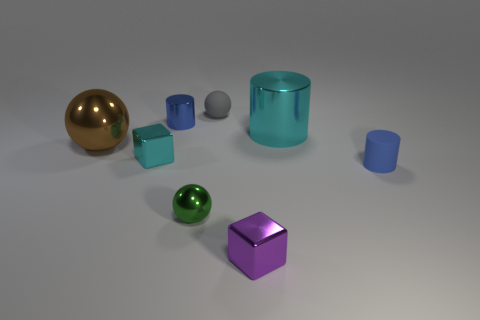There is another cylinder that is the same color as the small metallic cylinder; what is its material?
Offer a terse response. Rubber. Are there fewer small gray rubber things on the left side of the cyan cube than large brown shiny spheres behind the purple cube?
Provide a succinct answer. Yes. Do the tiny cylinder that is behind the small cyan metallic block and the rubber thing in front of the large cyan thing have the same color?
Offer a very short reply. Yes. Are there any brown spheres that have the same material as the big cylinder?
Keep it short and to the point. Yes. There is a metal block that is on the left side of the metal block that is to the right of the gray object; what is its size?
Your response must be concise. Small. Is the number of things greater than the number of large matte cubes?
Offer a terse response. Yes. Does the blue cylinder that is behind the brown metal thing have the same size as the tiny cyan metallic thing?
Your response must be concise. Yes. What number of tiny shiny objects have the same color as the small rubber cylinder?
Provide a short and direct response. 1. Do the large cyan thing and the small gray rubber object have the same shape?
Offer a terse response. No. Are there any other things that are the same size as the green metallic thing?
Your answer should be very brief. Yes. 